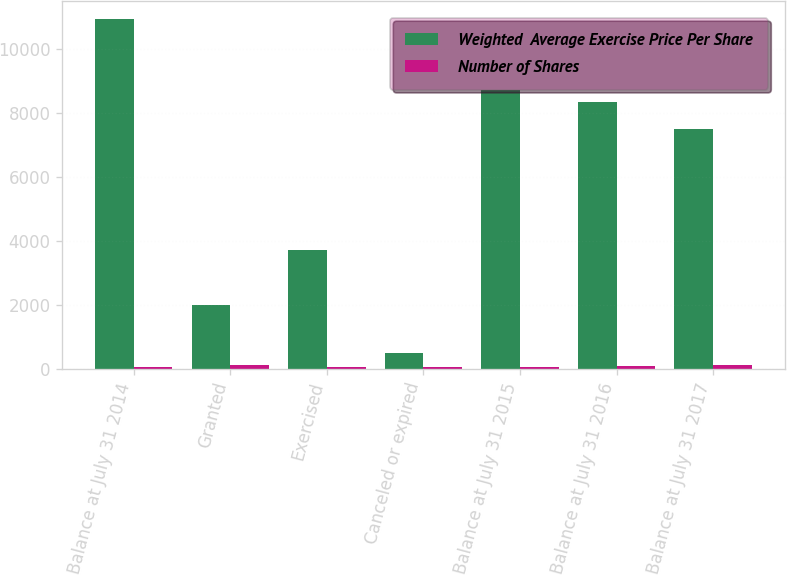<chart> <loc_0><loc_0><loc_500><loc_500><stacked_bar_chart><ecel><fcel>Balance at July 31 2014<fcel>Granted<fcel>Exercised<fcel>Canceled or expired<fcel>Balance at July 31 2015<fcel>Balance at July 31 2016<fcel>Balance at July 31 2017<nl><fcel>Weighted  Average Exercise Price Per Share<fcel>10938<fcel>1981<fcel>3704<fcel>502<fcel>8713<fcel>8346<fcel>7488<nl><fcel>Number of Shares<fcel>52.67<fcel>106.86<fcel>41.65<fcel>62.32<fcel>69.13<fcel>88.55<fcel>104.5<nl></chart> 